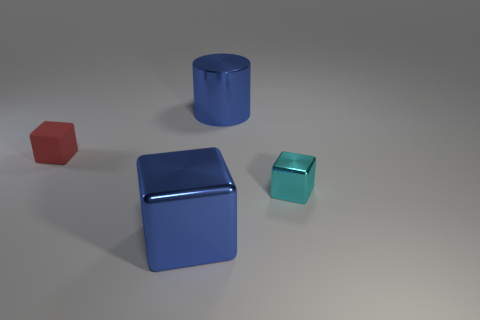Subtract all blue metal cubes. How many cubes are left? 2 Add 1 large blue shiny cubes. How many objects exist? 5 Subtract 0 yellow cylinders. How many objects are left? 4 Subtract all cylinders. How many objects are left? 3 Subtract 3 blocks. How many blocks are left? 0 Subtract all yellow blocks. Subtract all yellow balls. How many blocks are left? 3 Subtract all large metal cubes. Subtract all large cylinders. How many objects are left? 2 Add 2 tiny cyan objects. How many tiny cyan objects are left? 3 Add 1 small cyan metallic cubes. How many small cyan metallic cubes exist? 2 